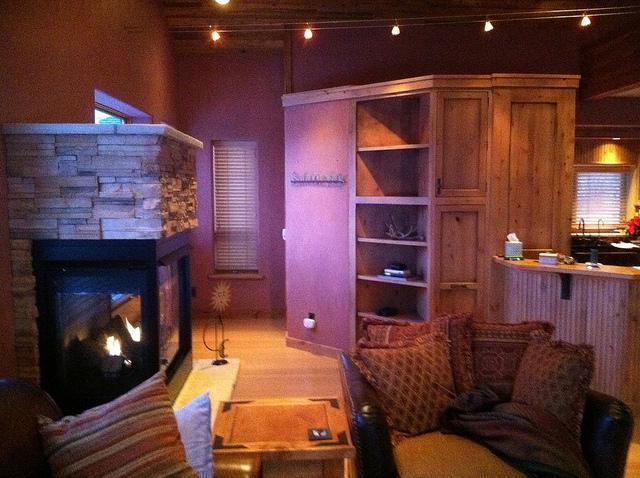How many dining tables can you see?
Give a very brief answer. 1. 